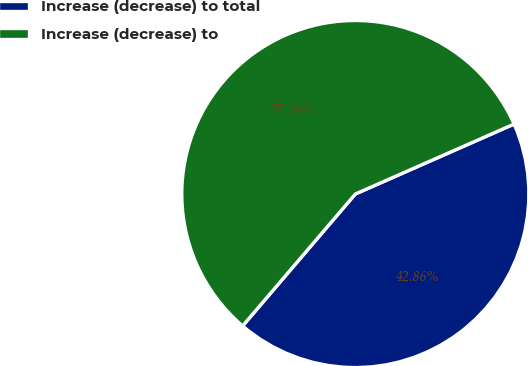<chart> <loc_0><loc_0><loc_500><loc_500><pie_chart><fcel>Increase (decrease) to total<fcel>Increase (decrease) to<nl><fcel>42.86%<fcel>57.14%<nl></chart> 